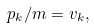<formula> <loc_0><loc_0><loc_500><loc_500>p _ { k } / m = v _ { k } ,</formula> 